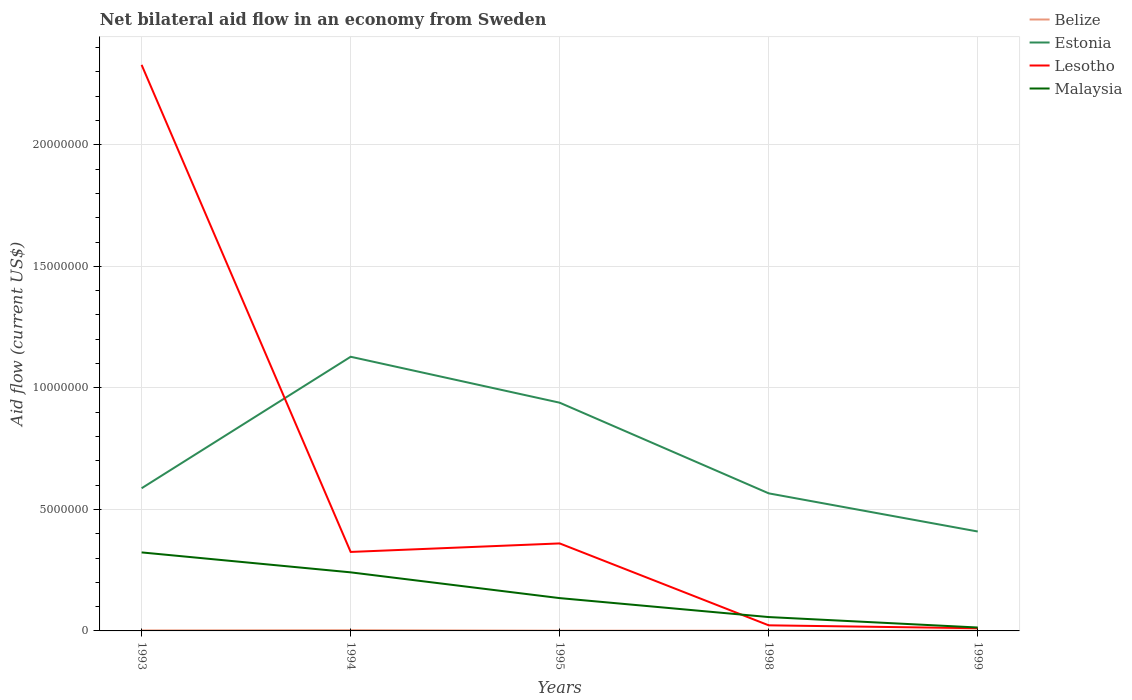How many different coloured lines are there?
Make the answer very short. 4. Is the number of lines equal to the number of legend labels?
Your answer should be compact. Yes. In which year was the net bilateral aid flow in Malaysia maximum?
Provide a short and direct response. 1999. What is the total net bilateral aid flow in Estonia in the graph?
Provide a short and direct response. -3.52e+06. Is the net bilateral aid flow in Estonia strictly greater than the net bilateral aid flow in Lesotho over the years?
Ensure brevity in your answer.  No. How many lines are there?
Keep it short and to the point. 4. Are the values on the major ticks of Y-axis written in scientific E-notation?
Give a very brief answer. No. Does the graph contain any zero values?
Provide a succinct answer. No. Does the graph contain grids?
Your answer should be very brief. Yes. Where does the legend appear in the graph?
Offer a terse response. Top right. How are the legend labels stacked?
Keep it short and to the point. Vertical. What is the title of the graph?
Provide a short and direct response. Net bilateral aid flow in an economy from Sweden. Does "Thailand" appear as one of the legend labels in the graph?
Offer a very short reply. No. What is the label or title of the Y-axis?
Give a very brief answer. Aid flow (current US$). What is the Aid flow (current US$) of Belize in 1993?
Give a very brief answer. 2.00e+04. What is the Aid flow (current US$) in Estonia in 1993?
Make the answer very short. 5.87e+06. What is the Aid flow (current US$) of Lesotho in 1993?
Offer a very short reply. 2.33e+07. What is the Aid flow (current US$) in Malaysia in 1993?
Give a very brief answer. 3.23e+06. What is the Aid flow (current US$) in Estonia in 1994?
Make the answer very short. 1.13e+07. What is the Aid flow (current US$) in Lesotho in 1994?
Keep it short and to the point. 3.25e+06. What is the Aid flow (current US$) of Malaysia in 1994?
Your answer should be very brief. 2.41e+06. What is the Aid flow (current US$) of Belize in 1995?
Your response must be concise. 10000. What is the Aid flow (current US$) in Estonia in 1995?
Your answer should be compact. 9.39e+06. What is the Aid flow (current US$) of Lesotho in 1995?
Your answer should be very brief. 3.60e+06. What is the Aid flow (current US$) of Malaysia in 1995?
Your response must be concise. 1.35e+06. What is the Aid flow (current US$) in Estonia in 1998?
Your answer should be very brief. 5.66e+06. What is the Aid flow (current US$) in Lesotho in 1998?
Your answer should be compact. 2.30e+05. What is the Aid flow (current US$) of Malaysia in 1998?
Give a very brief answer. 5.70e+05. What is the Aid flow (current US$) in Belize in 1999?
Keep it short and to the point. 10000. What is the Aid flow (current US$) in Estonia in 1999?
Provide a succinct answer. 4.09e+06. What is the Aid flow (current US$) in Lesotho in 1999?
Your response must be concise. 1.10e+05. Across all years, what is the maximum Aid flow (current US$) of Estonia?
Give a very brief answer. 1.13e+07. Across all years, what is the maximum Aid flow (current US$) in Lesotho?
Offer a terse response. 2.33e+07. Across all years, what is the maximum Aid flow (current US$) in Malaysia?
Offer a very short reply. 3.23e+06. Across all years, what is the minimum Aid flow (current US$) in Estonia?
Give a very brief answer. 4.09e+06. Across all years, what is the minimum Aid flow (current US$) of Lesotho?
Your response must be concise. 1.10e+05. What is the total Aid flow (current US$) in Belize in the graph?
Provide a succinct answer. 8.00e+04. What is the total Aid flow (current US$) in Estonia in the graph?
Make the answer very short. 3.63e+07. What is the total Aid flow (current US$) in Lesotho in the graph?
Your response must be concise. 3.05e+07. What is the total Aid flow (current US$) in Malaysia in the graph?
Offer a terse response. 7.70e+06. What is the difference between the Aid flow (current US$) in Belize in 1993 and that in 1994?
Make the answer very short. -10000. What is the difference between the Aid flow (current US$) of Estonia in 1993 and that in 1994?
Provide a succinct answer. -5.41e+06. What is the difference between the Aid flow (current US$) of Lesotho in 1993 and that in 1994?
Make the answer very short. 2.00e+07. What is the difference between the Aid flow (current US$) of Malaysia in 1993 and that in 1994?
Provide a succinct answer. 8.20e+05. What is the difference between the Aid flow (current US$) of Estonia in 1993 and that in 1995?
Offer a terse response. -3.52e+06. What is the difference between the Aid flow (current US$) in Lesotho in 1993 and that in 1995?
Ensure brevity in your answer.  1.97e+07. What is the difference between the Aid flow (current US$) of Malaysia in 1993 and that in 1995?
Keep it short and to the point. 1.88e+06. What is the difference between the Aid flow (current US$) in Belize in 1993 and that in 1998?
Offer a very short reply. 10000. What is the difference between the Aid flow (current US$) of Lesotho in 1993 and that in 1998?
Provide a short and direct response. 2.31e+07. What is the difference between the Aid flow (current US$) in Malaysia in 1993 and that in 1998?
Offer a terse response. 2.66e+06. What is the difference between the Aid flow (current US$) in Estonia in 1993 and that in 1999?
Give a very brief answer. 1.78e+06. What is the difference between the Aid flow (current US$) in Lesotho in 1993 and that in 1999?
Give a very brief answer. 2.32e+07. What is the difference between the Aid flow (current US$) in Malaysia in 1993 and that in 1999?
Keep it short and to the point. 3.09e+06. What is the difference between the Aid flow (current US$) in Belize in 1994 and that in 1995?
Make the answer very short. 2.00e+04. What is the difference between the Aid flow (current US$) of Estonia in 1994 and that in 1995?
Give a very brief answer. 1.89e+06. What is the difference between the Aid flow (current US$) in Lesotho in 1994 and that in 1995?
Provide a succinct answer. -3.50e+05. What is the difference between the Aid flow (current US$) of Malaysia in 1994 and that in 1995?
Your answer should be compact. 1.06e+06. What is the difference between the Aid flow (current US$) in Belize in 1994 and that in 1998?
Offer a very short reply. 2.00e+04. What is the difference between the Aid flow (current US$) in Estonia in 1994 and that in 1998?
Ensure brevity in your answer.  5.62e+06. What is the difference between the Aid flow (current US$) in Lesotho in 1994 and that in 1998?
Keep it short and to the point. 3.02e+06. What is the difference between the Aid flow (current US$) in Malaysia in 1994 and that in 1998?
Provide a succinct answer. 1.84e+06. What is the difference between the Aid flow (current US$) in Estonia in 1994 and that in 1999?
Give a very brief answer. 7.19e+06. What is the difference between the Aid flow (current US$) of Lesotho in 1994 and that in 1999?
Keep it short and to the point. 3.14e+06. What is the difference between the Aid flow (current US$) in Malaysia in 1994 and that in 1999?
Ensure brevity in your answer.  2.27e+06. What is the difference between the Aid flow (current US$) in Estonia in 1995 and that in 1998?
Provide a short and direct response. 3.73e+06. What is the difference between the Aid flow (current US$) of Lesotho in 1995 and that in 1998?
Ensure brevity in your answer.  3.37e+06. What is the difference between the Aid flow (current US$) of Malaysia in 1995 and that in 1998?
Your answer should be very brief. 7.80e+05. What is the difference between the Aid flow (current US$) in Belize in 1995 and that in 1999?
Your answer should be compact. 0. What is the difference between the Aid flow (current US$) of Estonia in 1995 and that in 1999?
Provide a succinct answer. 5.30e+06. What is the difference between the Aid flow (current US$) in Lesotho in 1995 and that in 1999?
Your answer should be very brief. 3.49e+06. What is the difference between the Aid flow (current US$) in Malaysia in 1995 and that in 1999?
Provide a short and direct response. 1.21e+06. What is the difference between the Aid flow (current US$) in Estonia in 1998 and that in 1999?
Give a very brief answer. 1.57e+06. What is the difference between the Aid flow (current US$) in Malaysia in 1998 and that in 1999?
Offer a very short reply. 4.30e+05. What is the difference between the Aid flow (current US$) in Belize in 1993 and the Aid flow (current US$) in Estonia in 1994?
Provide a short and direct response. -1.13e+07. What is the difference between the Aid flow (current US$) in Belize in 1993 and the Aid flow (current US$) in Lesotho in 1994?
Keep it short and to the point. -3.23e+06. What is the difference between the Aid flow (current US$) in Belize in 1993 and the Aid flow (current US$) in Malaysia in 1994?
Make the answer very short. -2.39e+06. What is the difference between the Aid flow (current US$) in Estonia in 1993 and the Aid flow (current US$) in Lesotho in 1994?
Provide a short and direct response. 2.62e+06. What is the difference between the Aid flow (current US$) in Estonia in 1993 and the Aid flow (current US$) in Malaysia in 1994?
Your response must be concise. 3.46e+06. What is the difference between the Aid flow (current US$) in Lesotho in 1993 and the Aid flow (current US$) in Malaysia in 1994?
Offer a terse response. 2.09e+07. What is the difference between the Aid flow (current US$) in Belize in 1993 and the Aid flow (current US$) in Estonia in 1995?
Your answer should be very brief. -9.37e+06. What is the difference between the Aid flow (current US$) of Belize in 1993 and the Aid flow (current US$) of Lesotho in 1995?
Make the answer very short. -3.58e+06. What is the difference between the Aid flow (current US$) of Belize in 1993 and the Aid flow (current US$) of Malaysia in 1995?
Your answer should be compact. -1.33e+06. What is the difference between the Aid flow (current US$) of Estonia in 1993 and the Aid flow (current US$) of Lesotho in 1995?
Your answer should be compact. 2.27e+06. What is the difference between the Aid flow (current US$) of Estonia in 1993 and the Aid flow (current US$) of Malaysia in 1995?
Offer a terse response. 4.52e+06. What is the difference between the Aid flow (current US$) in Lesotho in 1993 and the Aid flow (current US$) in Malaysia in 1995?
Provide a succinct answer. 2.19e+07. What is the difference between the Aid flow (current US$) of Belize in 1993 and the Aid flow (current US$) of Estonia in 1998?
Give a very brief answer. -5.64e+06. What is the difference between the Aid flow (current US$) in Belize in 1993 and the Aid flow (current US$) in Lesotho in 1998?
Provide a short and direct response. -2.10e+05. What is the difference between the Aid flow (current US$) in Belize in 1993 and the Aid flow (current US$) in Malaysia in 1998?
Ensure brevity in your answer.  -5.50e+05. What is the difference between the Aid flow (current US$) in Estonia in 1993 and the Aid flow (current US$) in Lesotho in 1998?
Keep it short and to the point. 5.64e+06. What is the difference between the Aid flow (current US$) in Estonia in 1993 and the Aid flow (current US$) in Malaysia in 1998?
Your response must be concise. 5.30e+06. What is the difference between the Aid flow (current US$) in Lesotho in 1993 and the Aid flow (current US$) in Malaysia in 1998?
Make the answer very short. 2.27e+07. What is the difference between the Aid flow (current US$) of Belize in 1993 and the Aid flow (current US$) of Estonia in 1999?
Your answer should be compact. -4.07e+06. What is the difference between the Aid flow (current US$) in Estonia in 1993 and the Aid flow (current US$) in Lesotho in 1999?
Your answer should be very brief. 5.76e+06. What is the difference between the Aid flow (current US$) of Estonia in 1993 and the Aid flow (current US$) of Malaysia in 1999?
Your answer should be very brief. 5.73e+06. What is the difference between the Aid flow (current US$) in Lesotho in 1993 and the Aid flow (current US$) in Malaysia in 1999?
Keep it short and to the point. 2.32e+07. What is the difference between the Aid flow (current US$) of Belize in 1994 and the Aid flow (current US$) of Estonia in 1995?
Give a very brief answer. -9.36e+06. What is the difference between the Aid flow (current US$) in Belize in 1994 and the Aid flow (current US$) in Lesotho in 1995?
Your response must be concise. -3.57e+06. What is the difference between the Aid flow (current US$) of Belize in 1994 and the Aid flow (current US$) of Malaysia in 1995?
Make the answer very short. -1.32e+06. What is the difference between the Aid flow (current US$) in Estonia in 1994 and the Aid flow (current US$) in Lesotho in 1995?
Your answer should be very brief. 7.68e+06. What is the difference between the Aid flow (current US$) of Estonia in 1994 and the Aid flow (current US$) of Malaysia in 1995?
Your answer should be very brief. 9.93e+06. What is the difference between the Aid flow (current US$) in Lesotho in 1994 and the Aid flow (current US$) in Malaysia in 1995?
Offer a very short reply. 1.90e+06. What is the difference between the Aid flow (current US$) of Belize in 1994 and the Aid flow (current US$) of Estonia in 1998?
Provide a succinct answer. -5.63e+06. What is the difference between the Aid flow (current US$) of Belize in 1994 and the Aid flow (current US$) of Malaysia in 1998?
Ensure brevity in your answer.  -5.40e+05. What is the difference between the Aid flow (current US$) of Estonia in 1994 and the Aid flow (current US$) of Lesotho in 1998?
Provide a short and direct response. 1.10e+07. What is the difference between the Aid flow (current US$) in Estonia in 1994 and the Aid flow (current US$) in Malaysia in 1998?
Make the answer very short. 1.07e+07. What is the difference between the Aid flow (current US$) of Lesotho in 1994 and the Aid flow (current US$) of Malaysia in 1998?
Your response must be concise. 2.68e+06. What is the difference between the Aid flow (current US$) in Belize in 1994 and the Aid flow (current US$) in Estonia in 1999?
Offer a very short reply. -4.06e+06. What is the difference between the Aid flow (current US$) of Belize in 1994 and the Aid flow (current US$) of Lesotho in 1999?
Offer a terse response. -8.00e+04. What is the difference between the Aid flow (current US$) of Belize in 1994 and the Aid flow (current US$) of Malaysia in 1999?
Provide a succinct answer. -1.10e+05. What is the difference between the Aid flow (current US$) of Estonia in 1994 and the Aid flow (current US$) of Lesotho in 1999?
Make the answer very short. 1.12e+07. What is the difference between the Aid flow (current US$) of Estonia in 1994 and the Aid flow (current US$) of Malaysia in 1999?
Provide a succinct answer. 1.11e+07. What is the difference between the Aid flow (current US$) of Lesotho in 1994 and the Aid flow (current US$) of Malaysia in 1999?
Make the answer very short. 3.11e+06. What is the difference between the Aid flow (current US$) in Belize in 1995 and the Aid flow (current US$) in Estonia in 1998?
Ensure brevity in your answer.  -5.65e+06. What is the difference between the Aid flow (current US$) of Belize in 1995 and the Aid flow (current US$) of Lesotho in 1998?
Make the answer very short. -2.20e+05. What is the difference between the Aid flow (current US$) in Belize in 1995 and the Aid flow (current US$) in Malaysia in 1998?
Your response must be concise. -5.60e+05. What is the difference between the Aid flow (current US$) of Estonia in 1995 and the Aid flow (current US$) of Lesotho in 1998?
Provide a short and direct response. 9.16e+06. What is the difference between the Aid flow (current US$) in Estonia in 1995 and the Aid flow (current US$) in Malaysia in 1998?
Keep it short and to the point. 8.82e+06. What is the difference between the Aid flow (current US$) in Lesotho in 1995 and the Aid flow (current US$) in Malaysia in 1998?
Offer a terse response. 3.03e+06. What is the difference between the Aid flow (current US$) of Belize in 1995 and the Aid flow (current US$) of Estonia in 1999?
Give a very brief answer. -4.08e+06. What is the difference between the Aid flow (current US$) of Estonia in 1995 and the Aid flow (current US$) of Lesotho in 1999?
Your answer should be compact. 9.28e+06. What is the difference between the Aid flow (current US$) of Estonia in 1995 and the Aid flow (current US$) of Malaysia in 1999?
Your response must be concise. 9.25e+06. What is the difference between the Aid flow (current US$) of Lesotho in 1995 and the Aid flow (current US$) of Malaysia in 1999?
Your answer should be compact. 3.46e+06. What is the difference between the Aid flow (current US$) in Belize in 1998 and the Aid flow (current US$) in Estonia in 1999?
Your answer should be very brief. -4.08e+06. What is the difference between the Aid flow (current US$) of Belize in 1998 and the Aid flow (current US$) of Malaysia in 1999?
Make the answer very short. -1.30e+05. What is the difference between the Aid flow (current US$) in Estonia in 1998 and the Aid flow (current US$) in Lesotho in 1999?
Provide a succinct answer. 5.55e+06. What is the difference between the Aid flow (current US$) of Estonia in 1998 and the Aid flow (current US$) of Malaysia in 1999?
Your answer should be compact. 5.52e+06. What is the average Aid flow (current US$) of Belize per year?
Provide a short and direct response. 1.60e+04. What is the average Aid flow (current US$) in Estonia per year?
Ensure brevity in your answer.  7.26e+06. What is the average Aid flow (current US$) of Lesotho per year?
Provide a succinct answer. 6.10e+06. What is the average Aid flow (current US$) in Malaysia per year?
Offer a terse response. 1.54e+06. In the year 1993, what is the difference between the Aid flow (current US$) of Belize and Aid flow (current US$) of Estonia?
Your answer should be compact. -5.85e+06. In the year 1993, what is the difference between the Aid flow (current US$) of Belize and Aid flow (current US$) of Lesotho?
Offer a terse response. -2.33e+07. In the year 1993, what is the difference between the Aid flow (current US$) in Belize and Aid flow (current US$) in Malaysia?
Provide a succinct answer. -3.21e+06. In the year 1993, what is the difference between the Aid flow (current US$) in Estonia and Aid flow (current US$) in Lesotho?
Provide a short and direct response. -1.74e+07. In the year 1993, what is the difference between the Aid flow (current US$) in Estonia and Aid flow (current US$) in Malaysia?
Your answer should be very brief. 2.64e+06. In the year 1993, what is the difference between the Aid flow (current US$) in Lesotho and Aid flow (current US$) in Malaysia?
Offer a terse response. 2.01e+07. In the year 1994, what is the difference between the Aid flow (current US$) in Belize and Aid flow (current US$) in Estonia?
Provide a succinct answer. -1.12e+07. In the year 1994, what is the difference between the Aid flow (current US$) of Belize and Aid flow (current US$) of Lesotho?
Your response must be concise. -3.22e+06. In the year 1994, what is the difference between the Aid flow (current US$) of Belize and Aid flow (current US$) of Malaysia?
Your response must be concise. -2.38e+06. In the year 1994, what is the difference between the Aid flow (current US$) of Estonia and Aid flow (current US$) of Lesotho?
Provide a succinct answer. 8.03e+06. In the year 1994, what is the difference between the Aid flow (current US$) of Estonia and Aid flow (current US$) of Malaysia?
Provide a succinct answer. 8.87e+06. In the year 1994, what is the difference between the Aid flow (current US$) in Lesotho and Aid flow (current US$) in Malaysia?
Provide a succinct answer. 8.40e+05. In the year 1995, what is the difference between the Aid flow (current US$) of Belize and Aid flow (current US$) of Estonia?
Give a very brief answer. -9.38e+06. In the year 1995, what is the difference between the Aid flow (current US$) in Belize and Aid flow (current US$) in Lesotho?
Give a very brief answer. -3.59e+06. In the year 1995, what is the difference between the Aid flow (current US$) of Belize and Aid flow (current US$) of Malaysia?
Keep it short and to the point. -1.34e+06. In the year 1995, what is the difference between the Aid flow (current US$) of Estonia and Aid flow (current US$) of Lesotho?
Offer a very short reply. 5.79e+06. In the year 1995, what is the difference between the Aid flow (current US$) of Estonia and Aid flow (current US$) of Malaysia?
Ensure brevity in your answer.  8.04e+06. In the year 1995, what is the difference between the Aid flow (current US$) of Lesotho and Aid flow (current US$) of Malaysia?
Keep it short and to the point. 2.25e+06. In the year 1998, what is the difference between the Aid flow (current US$) of Belize and Aid flow (current US$) of Estonia?
Your answer should be very brief. -5.65e+06. In the year 1998, what is the difference between the Aid flow (current US$) in Belize and Aid flow (current US$) in Lesotho?
Give a very brief answer. -2.20e+05. In the year 1998, what is the difference between the Aid flow (current US$) of Belize and Aid flow (current US$) of Malaysia?
Give a very brief answer. -5.60e+05. In the year 1998, what is the difference between the Aid flow (current US$) in Estonia and Aid flow (current US$) in Lesotho?
Your answer should be very brief. 5.43e+06. In the year 1998, what is the difference between the Aid flow (current US$) in Estonia and Aid flow (current US$) in Malaysia?
Offer a terse response. 5.09e+06. In the year 1999, what is the difference between the Aid flow (current US$) in Belize and Aid flow (current US$) in Estonia?
Provide a succinct answer. -4.08e+06. In the year 1999, what is the difference between the Aid flow (current US$) of Belize and Aid flow (current US$) of Lesotho?
Your answer should be compact. -1.00e+05. In the year 1999, what is the difference between the Aid flow (current US$) of Estonia and Aid flow (current US$) of Lesotho?
Provide a short and direct response. 3.98e+06. In the year 1999, what is the difference between the Aid flow (current US$) of Estonia and Aid flow (current US$) of Malaysia?
Offer a terse response. 3.95e+06. What is the ratio of the Aid flow (current US$) of Belize in 1993 to that in 1994?
Make the answer very short. 0.67. What is the ratio of the Aid flow (current US$) in Estonia in 1993 to that in 1994?
Make the answer very short. 0.52. What is the ratio of the Aid flow (current US$) in Lesotho in 1993 to that in 1994?
Your answer should be very brief. 7.17. What is the ratio of the Aid flow (current US$) of Malaysia in 1993 to that in 1994?
Keep it short and to the point. 1.34. What is the ratio of the Aid flow (current US$) in Estonia in 1993 to that in 1995?
Your answer should be compact. 0.63. What is the ratio of the Aid flow (current US$) in Lesotho in 1993 to that in 1995?
Provide a succinct answer. 6.47. What is the ratio of the Aid flow (current US$) of Malaysia in 1993 to that in 1995?
Make the answer very short. 2.39. What is the ratio of the Aid flow (current US$) of Estonia in 1993 to that in 1998?
Provide a succinct answer. 1.04. What is the ratio of the Aid flow (current US$) in Lesotho in 1993 to that in 1998?
Offer a terse response. 101.26. What is the ratio of the Aid flow (current US$) of Malaysia in 1993 to that in 1998?
Ensure brevity in your answer.  5.67. What is the ratio of the Aid flow (current US$) of Estonia in 1993 to that in 1999?
Give a very brief answer. 1.44. What is the ratio of the Aid flow (current US$) in Lesotho in 1993 to that in 1999?
Provide a short and direct response. 211.73. What is the ratio of the Aid flow (current US$) in Malaysia in 1993 to that in 1999?
Ensure brevity in your answer.  23.07. What is the ratio of the Aid flow (current US$) of Belize in 1994 to that in 1995?
Offer a terse response. 3. What is the ratio of the Aid flow (current US$) in Estonia in 1994 to that in 1995?
Keep it short and to the point. 1.2. What is the ratio of the Aid flow (current US$) in Lesotho in 1994 to that in 1995?
Offer a terse response. 0.9. What is the ratio of the Aid flow (current US$) in Malaysia in 1994 to that in 1995?
Your response must be concise. 1.79. What is the ratio of the Aid flow (current US$) in Estonia in 1994 to that in 1998?
Your answer should be compact. 1.99. What is the ratio of the Aid flow (current US$) in Lesotho in 1994 to that in 1998?
Your response must be concise. 14.13. What is the ratio of the Aid flow (current US$) of Malaysia in 1994 to that in 1998?
Offer a terse response. 4.23. What is the ratio of the Aid flow (current US$) in Belize in 1994 to that in 1999?
Provide a succinct answer. 3. What is the ratio of the Aid flow (current US$) of Estonia in 1994 to that in 1999?
Give a very brief answer. 2.76. What is the ratio of the Aid flow (current US$) of Lesotho in 1994 to that in 1999?
Your answer should be compact. 29.55. What is the ratio of the Aid flow (current US$) of Malaysia in 1994 to that in 1999?
Offer a terse response. 17.21. What is the ratio of the Aid flow (current US$) in Estonia in 1995 to that in 1998?
Your answer should be very brief. 1.66. What is the ratio of the Aid flow (current US$) of Lesotho in 1995 to that in 1998?
Your response must be concise. 15.65. What is the ratio of the Aid flow (current US$) of Malaysia in 1995 to that in 1998?
Ensure brevity in your answer.  2.37. What is the ratio of the Aid flow (current US$) of Estonia in 1995 to that in 1999?
Offer a very short reply. 2.3. What is the ratio of the Aid flow (current US$) in Lesotho in 1995 to that in 1999?
Give a very brief answer. 32.73. What is the ratio of the Aid flow (current US$) of Malaysia in 1995 to that in 1999?
Provide a succinct answer. 9.64. What is the ratio of the Aid flow (current US$) of Estonia in 1998 to that in 1999?
Provide a short and direct response. 1.38. What is the ratio of the Aid flow (current US$) of Lesotho in 1998 to that in 1999?
Provide a succinct answer. 2.09. What is the ratio of the Aid flow (current US$) of Malaysia in 1998 to that in 1999?
Your response must be concise. 4.07. What is the difference between the highest and the second highest Aid flow (current US$) in Belize?
Make the answer very short. 10000. What is the difference between the highest and the second highest Aid flow (current US$) of Estonia?
Your answer should be compact. 1.89e+06. What is the difference between the highest and the second highest Aid flow (current US$) in Lesotho?
Keep it short and to the point. 1.97e+07. What is the difference between the highest and the second highest Aid flow (current US$) in Malaysia?
Your response must be concise. 8.20e+05. What is the difference between the highest and the lowest Aid flow (current US$) of Belize?
Your answer should be compact. 2.00e+04. What is the difference between the highest and the lowest Aid flow (current US$) in Estonia?
Offer a very short reply. 7.19e+06. What is the difference between the highest and the lowest Aid flow (current US$) of Lesotho?
Provide a succinct answer. 2.32e+07. What is the difference between the highest and the lowest Aid flow (current US$) of Malaysia?
Your answer should be compact. 3.09e+06. 